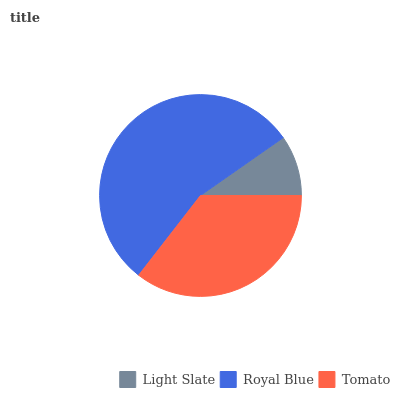Is Light Slate the minimum?
Answer yes or no. Yes. Is Royal Blue the maximum?
Answer yes or no. Yes. Is Tomato the minimum?
Answer yes or no. No. Is Tomato the maximum?
Answer yes or no. No. Is Royal Blue greater than Tomato?
Answer yes or no. Yes. Is Tomato less than Royal Blue?
Answer yes or no. Yes. Is Tomato greater than Royal Blue?
Answer yes or no. No. Is Royal Blue less than Tomato?
Answer yes or no. No. Is Tomato the high median?
Answer yes or no. Yes. Is Tomato the low median?
Answer yes or no. Yes. Is Royal Blue the high median?
Answer yes or no. No. Is Royal Blue the low median?
Answer yes or no. No. 